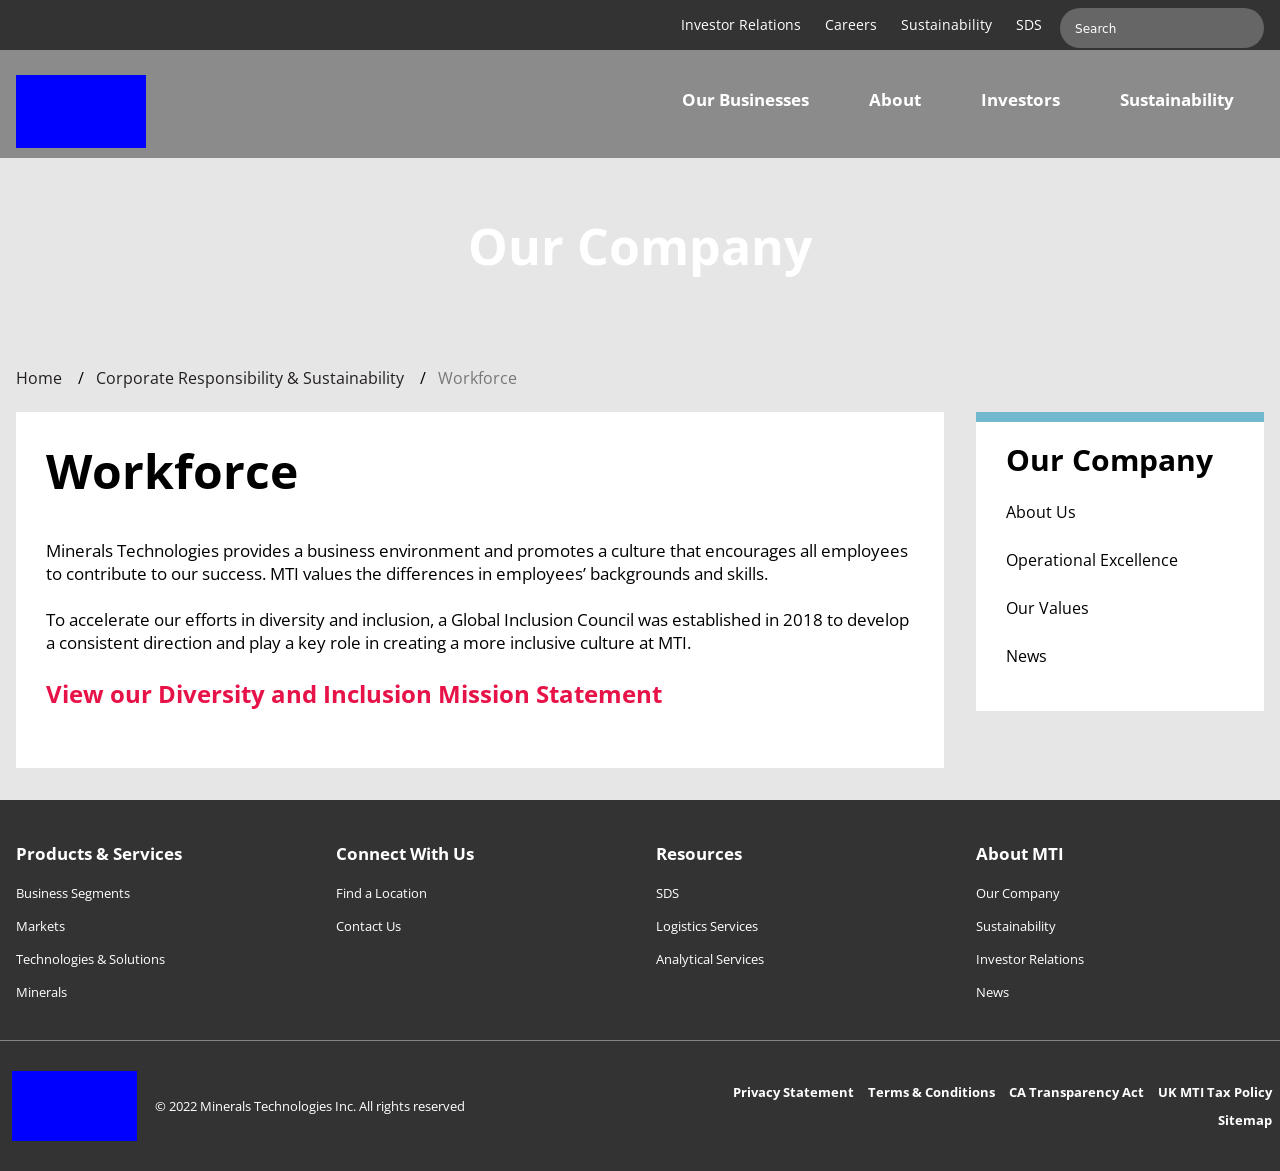Regarding the layout, how does the website image use visual design to make navigation easier? The website image uses a clean and structured layout that aids in navigation. Key sections are compartmentalized clearly with headers, while a minimalist color palette helps important elements like links and buttons stand out. This approach makes the site user-friendly by reducing visual clutter and emphasizing navigational cues. 